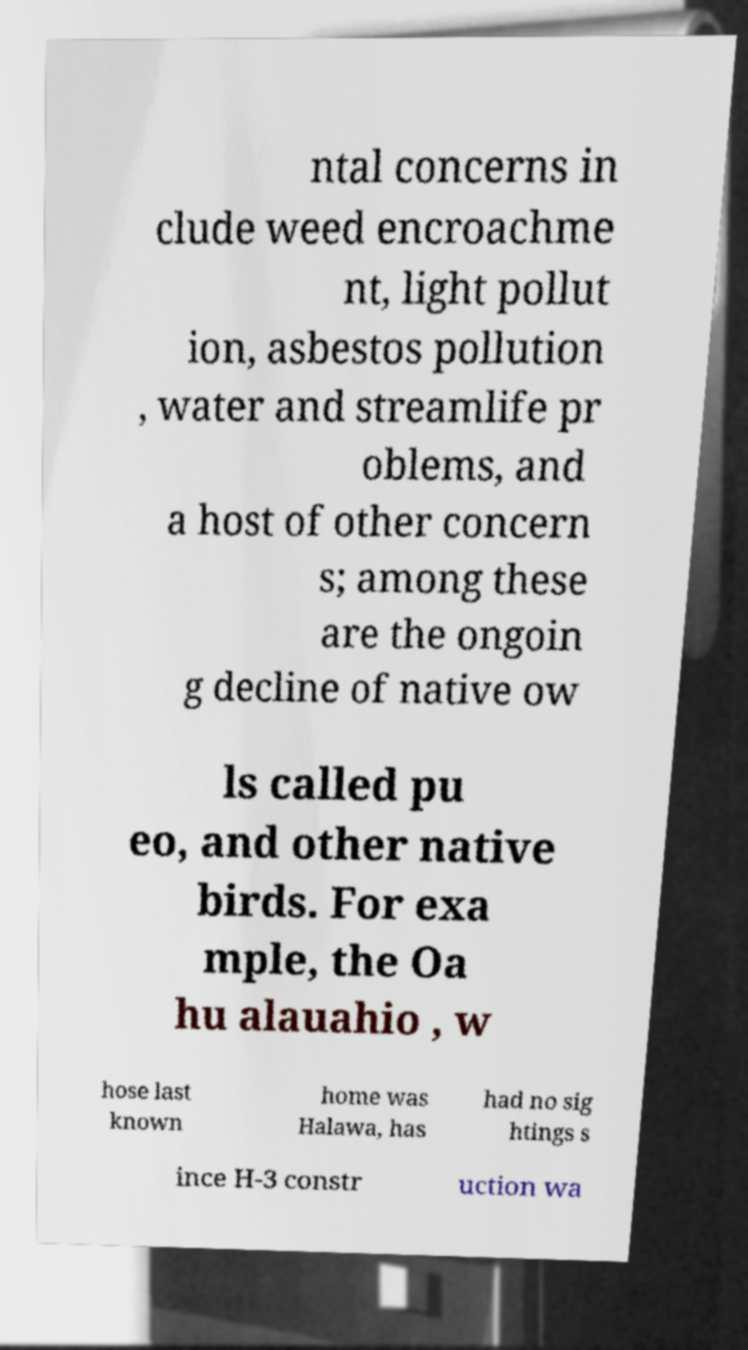For documentation purposes, I need the text within this image transcribed. Could you provide that? ntal concerns in clude weed encroachme nt, light pollut ion, asbestos pollution , water and streamlife pr oblems, and a host of other concern s; among these are the ongoin g decline of native ow ls called pu eo, and other native birds. For exa mple, the Oa hu alauahio , w hose last known home was Halawa, has had no sig htings s ince H-3 constr uction wa 